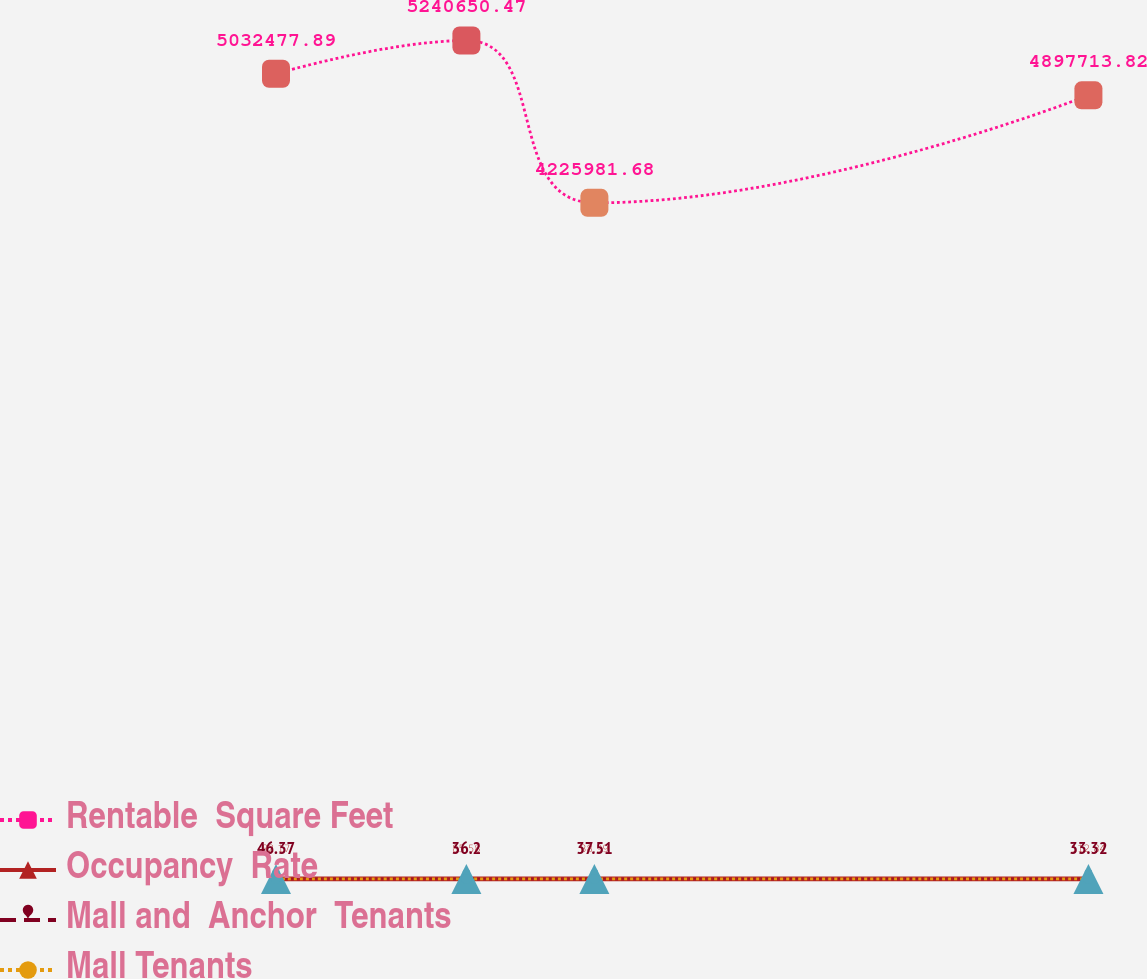Convert chart. <chart><loc_0><loc_0><loc_500><loc_500><line_chart><ecel><fcel>Rentable  Square Feet<fcel>Occupancy  Rate<fcel>Mall and  Anchor  Tenants<fcel>Mall Tenants<nl><fcel>1621.12<fcel>5.03248e+06<fcel>82.17<fcel>46.37<fcel>20.89<nl><fcel>1737.16<fcel>5.24065e+06<fcel>85.58<fcel>36.2<fcel>23.46<nl><fcel>1815.17<fcel>4.22598e+06<fcel>88.99<fcel>37.51<fcel>22.85<nl><fcel>2116.25<fcel>4.89771e+06<fcel>112.84<fcel>33.32<fcel>16.95<nl><fcel>2401.22<fcel>5.47122e+06<fcel>78.7<fcel>38.9<fcel>18.94<nl></chart> 